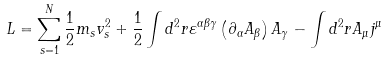Convert formula to latex. <formula><loc_0><loc_0><loc_500><loc_500>L = \sum _ { s = 1 } ^ { N } \frac { 1 } { 2 } m _ { s } v _ { s } ^ { 2 } + \frac { 1 } { 2 } \int d ^ { 2 } r \varepsilon ^ { \alpha \beta \gamma } \left ( \partial _ { \alpha } A _ { \beta } \right ) A _ { \gamma } - \int d ^ { 2 } r A _ { \mu } j ^ { \mu }</formula> 